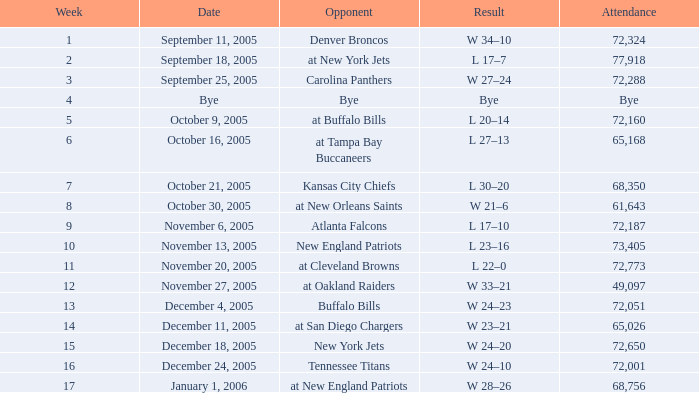What is the Date of the game with an attendance of 72,051 after Week 9? December 4, 2005. 